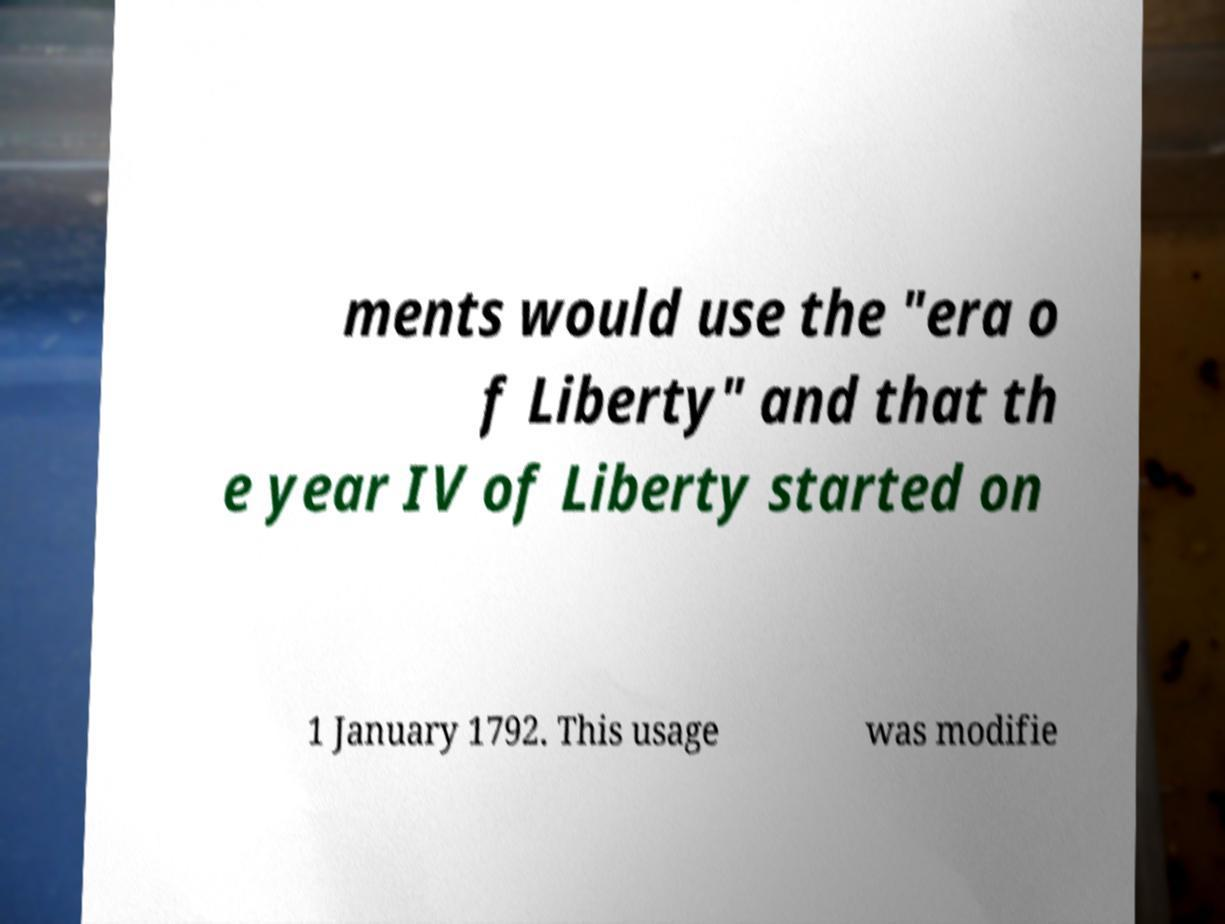Please identify and transcribe the text found in this image. ments would use the "era o f Liberty" and that th e year IV of Liberty started on 1 January 1792. This usage was modifie 